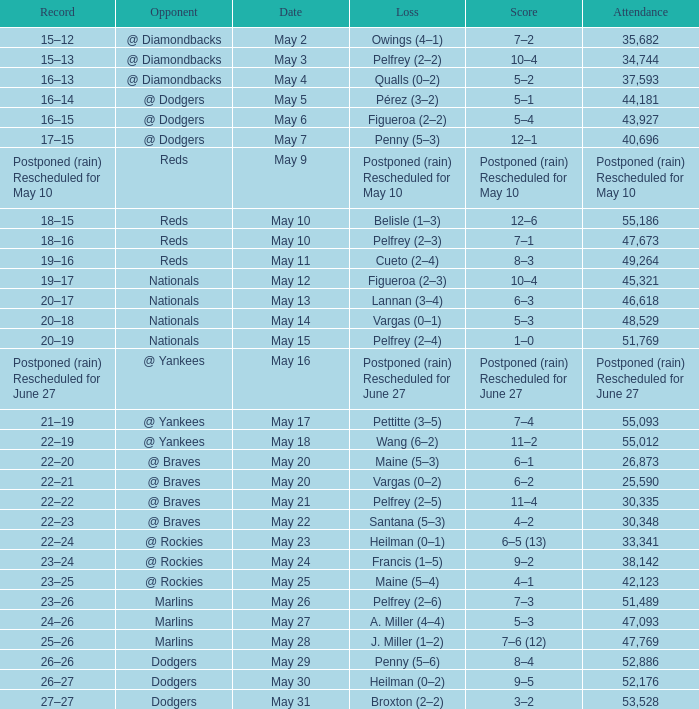Loss of postponed (rain) rescheduled for may 10 had what record? Postponed (rain) Rescheduled for May 10. Parse the table in full. {'header': ['Record', 'Opponent', 'Date', 'Loss', 'Score', 'Attendance'], 'rows': [['15–12', '@ Diamondbacks', 'May 2', 'Owings (4–1)', '7–2', '35,682'], ['15–13', '@ Diamondbacks', 'May 3', 'Pelfrey (2–2)', '10–4', '34,744'], ['16–13', '@ Diamondbacks', 'May 4', 'Qualls (0–2)', '5–2', '37,593'], ['16–14', '@ Dodgers', 'May 5', 'Pérez (3–2)', '5–1', '44,181'], ['16–15', '@ Dodgers', 'May 6', 'Figueroa (2–2)', '5–4', '43,927'], ['17–15', '@ Dodgers', 'May 7', 'Penny (5–3)', '12–1', '40,696'], ['Postponed (rain) Rescheduled for May 10', 'Reds', 'May 9', 'Postponed (rain) Rescheduled for May 10', 'Postponed (rain) Rescheduled for May 10', 'Postponed (rain) Rescheduled for May 10'], ['18–15', 'Reds', 'May 10', 'Belisle (1–3)', '12–6', '55,186'], ['18–16', 'Reds', 'May 10', 'Pelfrey (2–3)', '7–1', '47,673'], ['19–16', 'Reds', 'May 11', 'Cueto (2–4)', '8–3', '49,264'], ['19–17', 'Nationals', 'May 12', 'Figueroa (2–3)', '10–4', '45,321'], ['20–17', 'Nationals', 'May 13', 'Lannan (3–4)', '6–3', '46,618'], ['20–18', 'Nationals', 'May 14', 'Vargas (0–1)', '5–3', '48,529'], ['20–19', 'Nationals', 'May 15', 'Pelfrey (2–4)', '1–0', '51,769'], ['Postponed (rain) Rescheduled for June 27', '@ Yankees', 'May 16', 'Postponed (rain) Rescheduled for June 27', 'Postponed (rain) Rescheduled for June 27', 'Postponed (rain) Rescheduled for June 27'], ['21–19', '@ Yankees', 'May 17', 'Pettitte (3–5)', '7–4', '55,093'], ['22–19', '@ Yankees', 'May 18', 'Wang (6–2)', '11–2', '55,012'], ['22–20', '@ Braves', 'May 20', 'Maine (5–3)', '6–1', '26,873'], ['22–21', '@ Braves', 'May 20', 'Vargas (0–2)', '6–2', '25,590'], ['22–22', '@ Braves', 'May 21', 'Pelfrey (2–5)', '11–4', '30,335'], ['22–23', '@ Braves', 'May 22', 'Santana (5–3)', '4–2', '30,348'], ['22–24', '@ Rockies', 'May 23', 'Heilman (0–1)', '6–5 (13)', '33,341'], ['23–24', '@ Rockies', 'May 24', 'Francis (1–5)', '9–2', '38,142'], ['23–25', '@ Rockies', 'May 25', 'Maine (5–4)', '4–1', '42,123'], ['23–26', 'Marlins', 'May 26', 'Pelfrey (2–6)', '7–3', '51,489'], ['24–26', 'Marlins', 'May 27', 'A. Miller (4–4)', '5–3', '47,093'], ['25–26', 'Marlins', 'May 28', 'J. Miller (1–2)', '7–6 (12)', '47,769'], ['26–26', 'Dodgers', 'May 29', 'Penny (5–6)', '8–4', '52,886'], ['26–27', 'Dodgers', 'May 30', 'Heilman (0–2)', '9–5', '52,176'], ['27–27', 'Dodgers', 'May 31', 'Broxton (2–2)', '3–2', '53,528']]} 